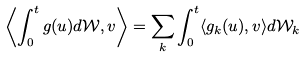Convert formula to latex. <formula><loc_0><loc_0><loc_500><loc_500>\left \langle \int _ { 0 } ^ { t } g ( u ) d \mathcal { W } , v \right \rangle = \sum _ { k } \int _ { 0 } ^ { t } \langle g _ { k } ( u ) , v \rangle d \mathcal { W } _ { k }</formula> 